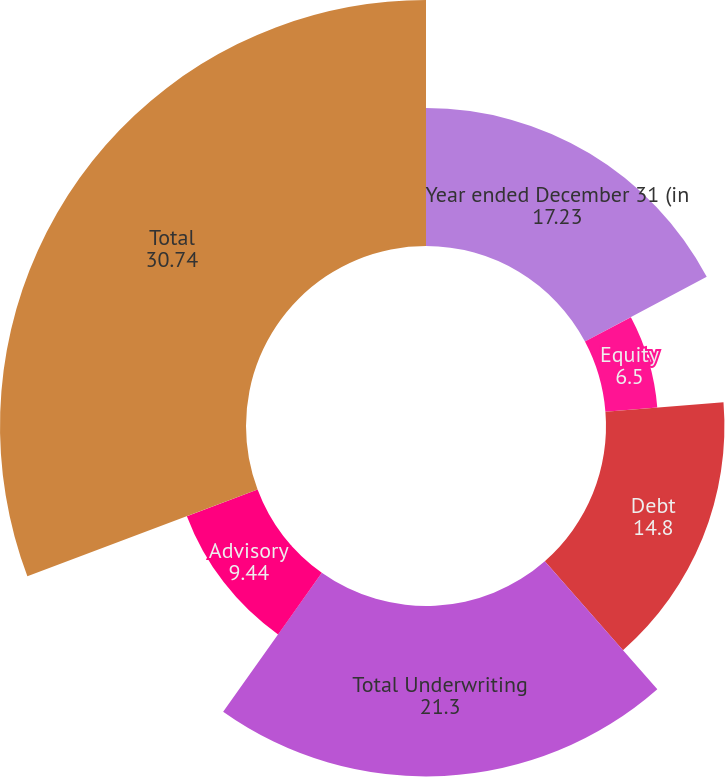Convert chart to OTSL. <chart><loc_0><loc_0><loc_500><loc_500><pie_chart><fcel>Year ended December 31 (in<fcel>Equity<fcel>Debt<fcel>Total Underwriting<fcel>Advisory<fcel>Total<nl><fcel>17.23%<fcel>6.5%<fcel>14.8%<fcel>21.3%<fcel>9.44%<fcel>30.74%<nl></chart> 